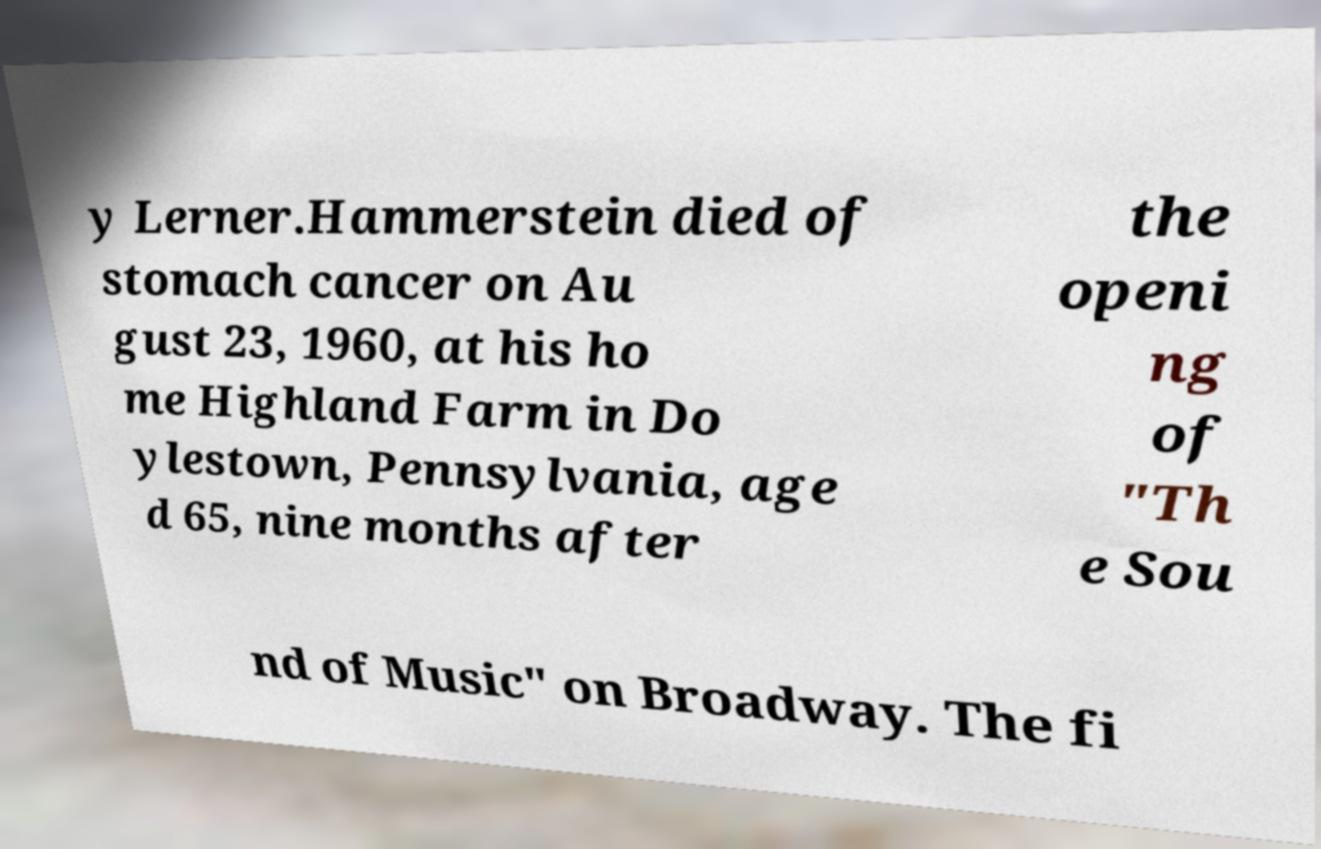Can you read and provide the text displayed in the image?This photo seems to have some interesting text. Can you extract and type it out for me? y Lerner.Hammerstein died of stomach cancer on Au gust 23, 1960, at his ho me Highland Farm in Do ylestown, Pennsylvania, age d 65, nine months after the openi ng of "Th e Sou nd of Music" on Broadway. The fi 